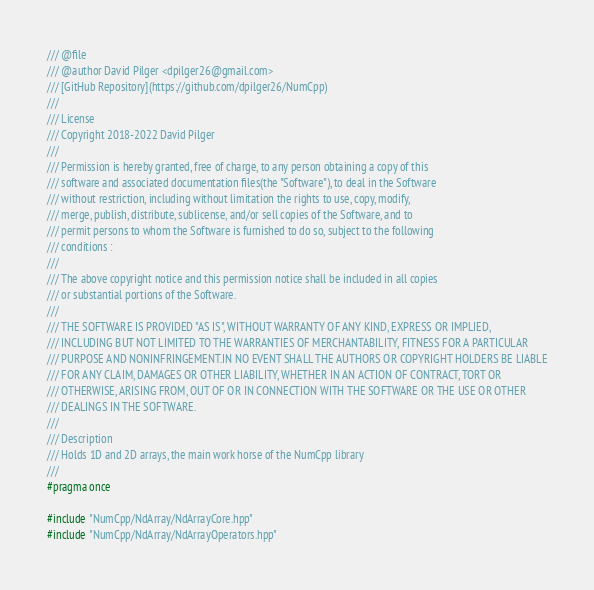Convert code to text. <code><loc_0><loc_0><loc_500><loc_500><_C++_>/// @file
/// @author David Pilger <dpilger26@gmail.com>
/// [GitHub Repository](https://github.com/dpilger26/NumCpp)
///
/// License
/// Copyright 2018-2022 David Pilger
///
/// Permission is hereby granted, free of charge, to any person obtaining a copy of this
/// software and associated documentation files(the "Software"), to deal in the Software
/// without restriction, including without limitation the rights to use, copy, modify,
/// merge, publish, distribute, sublicense, and/or sell copies of the Software, and to
/// permit persons to whom the Software is furnished to do so, subject to the following
/// conditions :
///
/// The above copyright notice and this permission notice shall be included in all copies
/// or substantial portions of the Software.
///
/// THE SOFTWARE IS PROVIDED "AS IS", WITHOUT WARRANTY OF ANY KIND, EXPRESS OR IMPLIED,
/// INCLUDING BUT NOT LIMITED TO THE WARRANTIES OF MERCHANTABILITY, FITNESS FOR A PARTICULAR
/// PURPOSE AND NONINFRINGEMENT.IN NO EVENT SHALL THE AUTHORS OR COPYRIGHT HOLDERS BE LIABLE
/// FOR ANY CLAIM, DAMAGES OR OTHER LIABILITY, WHETHER IN AN ACTION OF CONTRACT, TORT OR
/// OTHERWISE, ARISING FROM, OUT OF OR IN CONNECTION WITH THE SOFTWARE OR THE USE OR OTHER
/// DEALINGS IN THE SOFTWARE.
///
/// Description
/// Holds 1D and 2D arrays, the main work horse of the NumCpp library
///
#pragma once

#include "NumCpp/NdArray/NdArrayCore.hpp"
#include "NumCpp/NdArray/NdArrayOperators.hpp"

</code> 